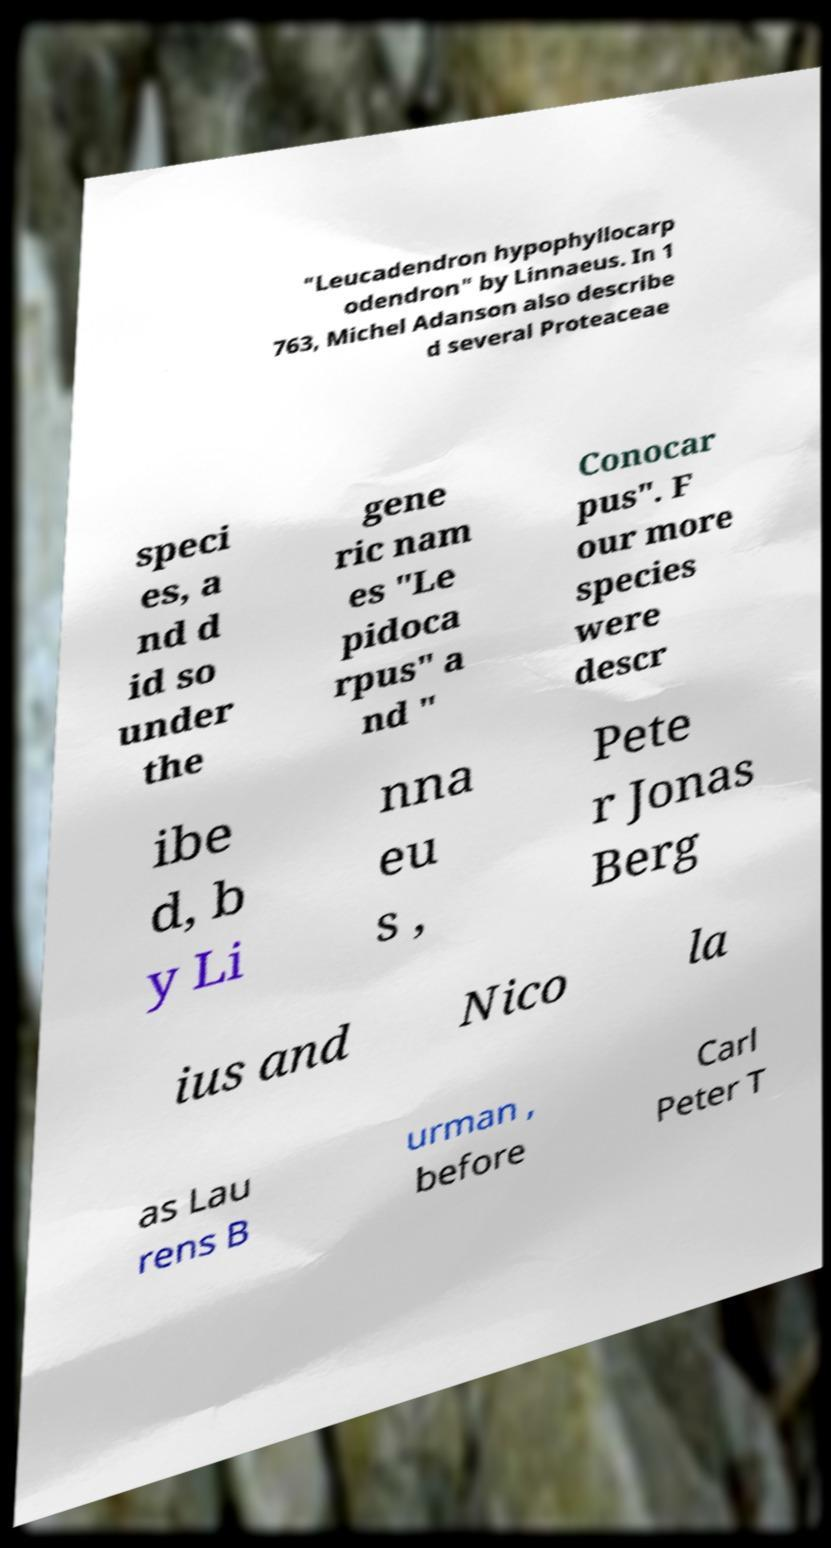Could you extract and type out the text from this image? "Leucadendron hypophyllocarp odendron" by Linnaeus. In 1 763, Michel Adanson also describe d several Proteaceae speci es, a nd d id so under the gene ric nam es "Le pidoca rpus" a nd " Conocar pus". F our more species were descr ibe d, b y Li nna eu s , Pete r Jonas Berg ius and Nico la as Lau rens B urman , before Carl Peter T 